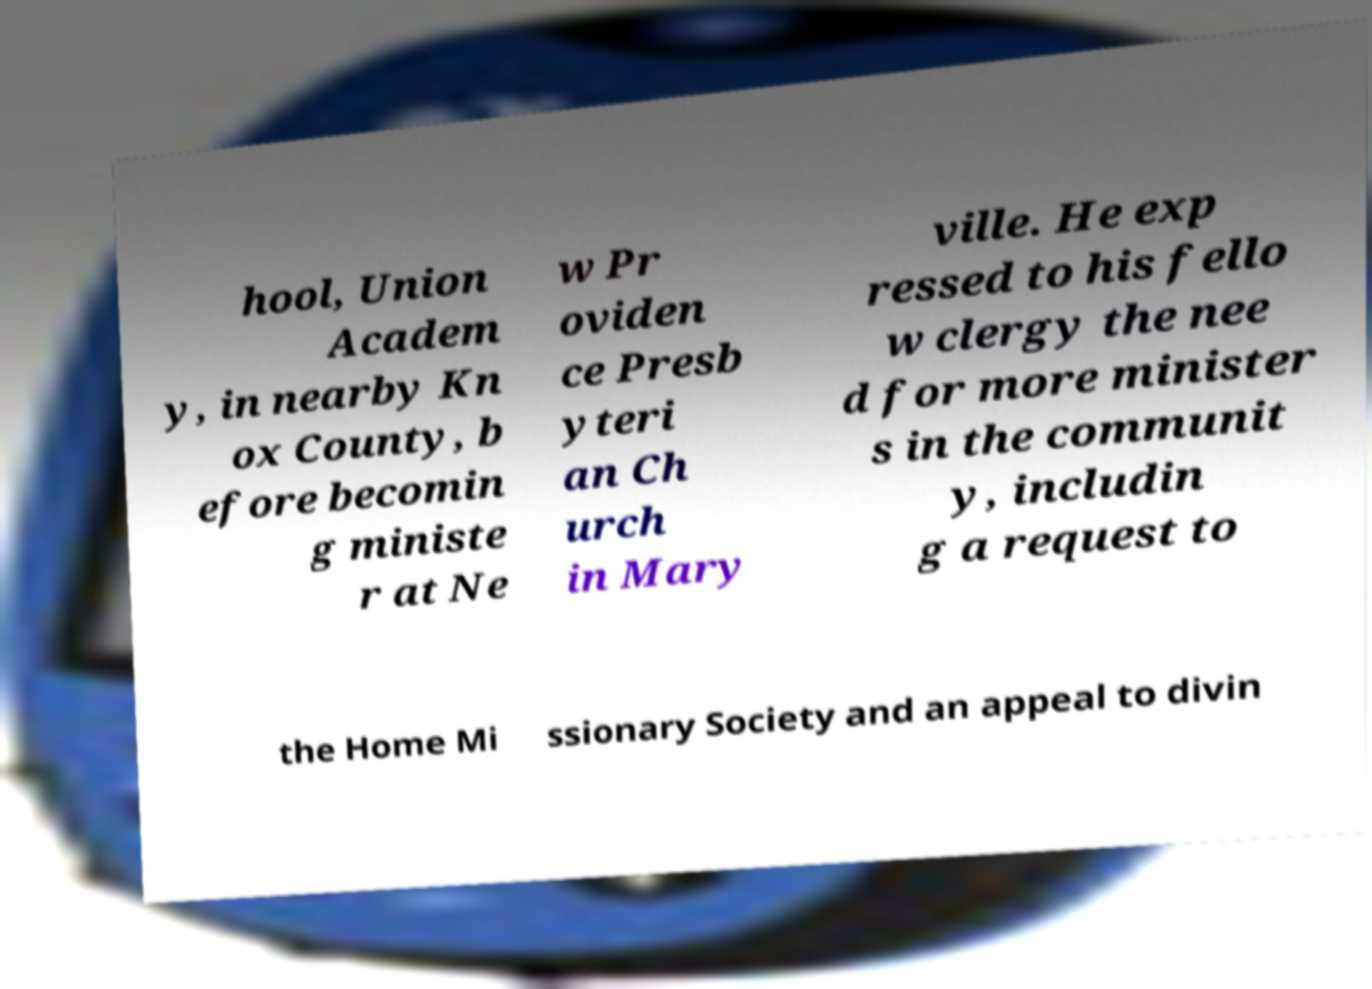Could you extract and type out the text from this image? hool, Union Academ y, in nearby Kn ox County, b efore becomin g ministe r at Ne w Pr oviden ce Presb yteri an Ch urch in Mary ville. He exp ressed to his fello w clergy the nee d for more minister s in the communit y, includin g a request to the Home Mi ssionary Society and an appeal to divin 